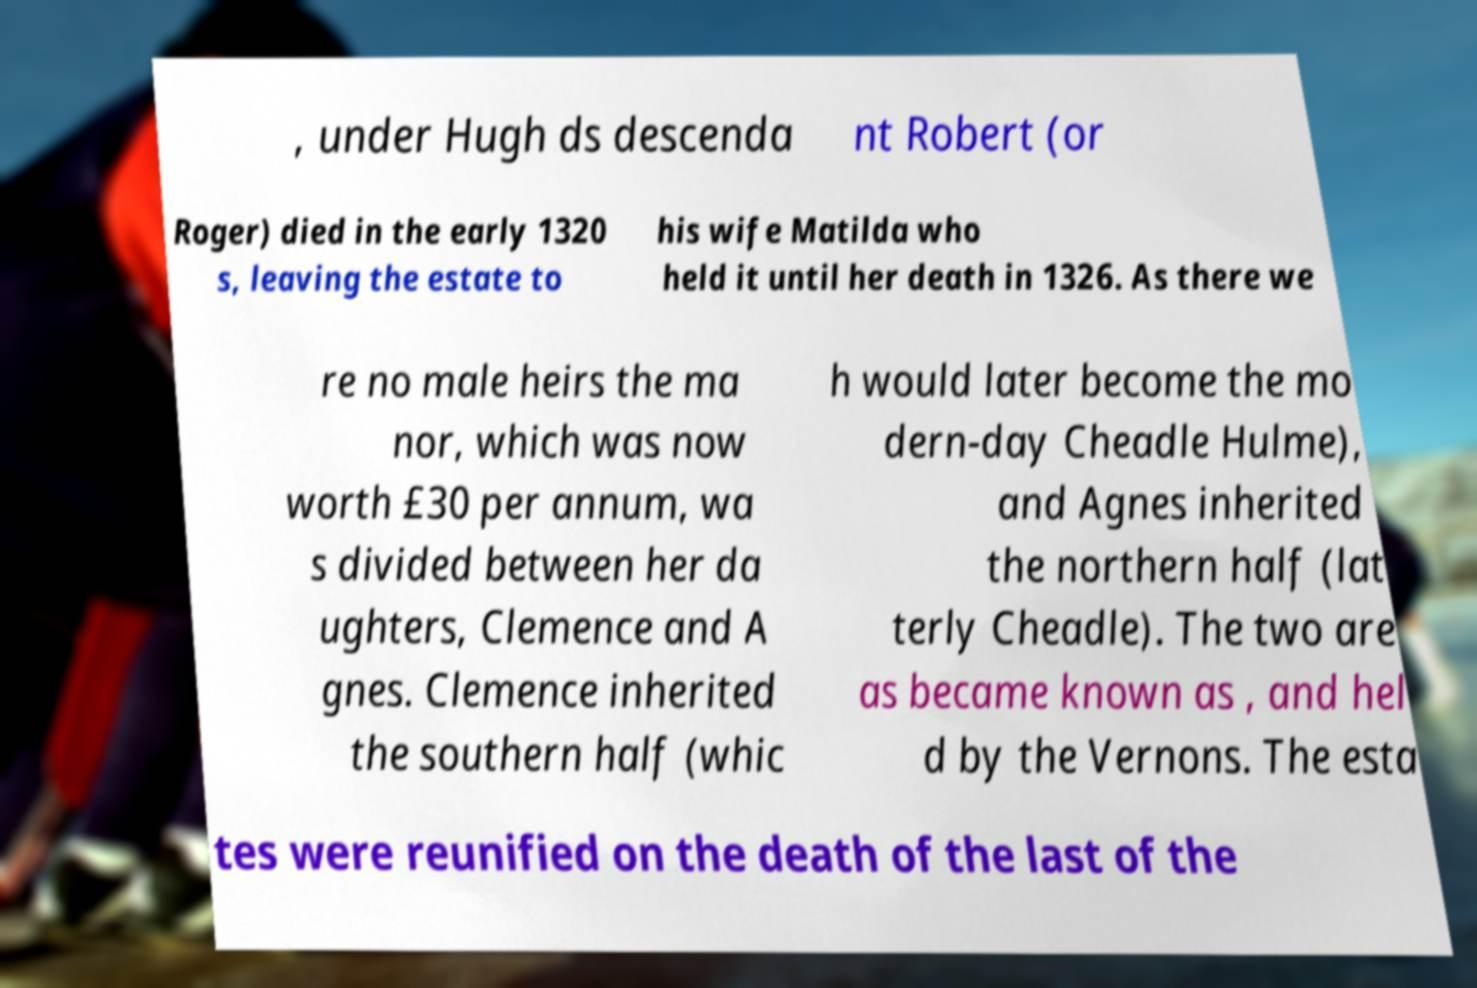Can you accurately transcribe the text from the provided image for me? , under Hugh ds descenda nt Robert (or Roger) died in the early 1320 s, leaving the estate to his wife Matilda who held it until her death in 1326. As there we re no male heirs the ma nor, which was now worth £30 per annum, wa s divided between her da ughters, Clemence and A gnes. Clemence inherited the southern half (whic h would later become the mo dern-day Cheadle Hulme), and Agnes inherited the northern half (lat terly Cheadle). The two are as became known as , and hel d by the Vernons. The esta tes were reunified on the death of the last of the 